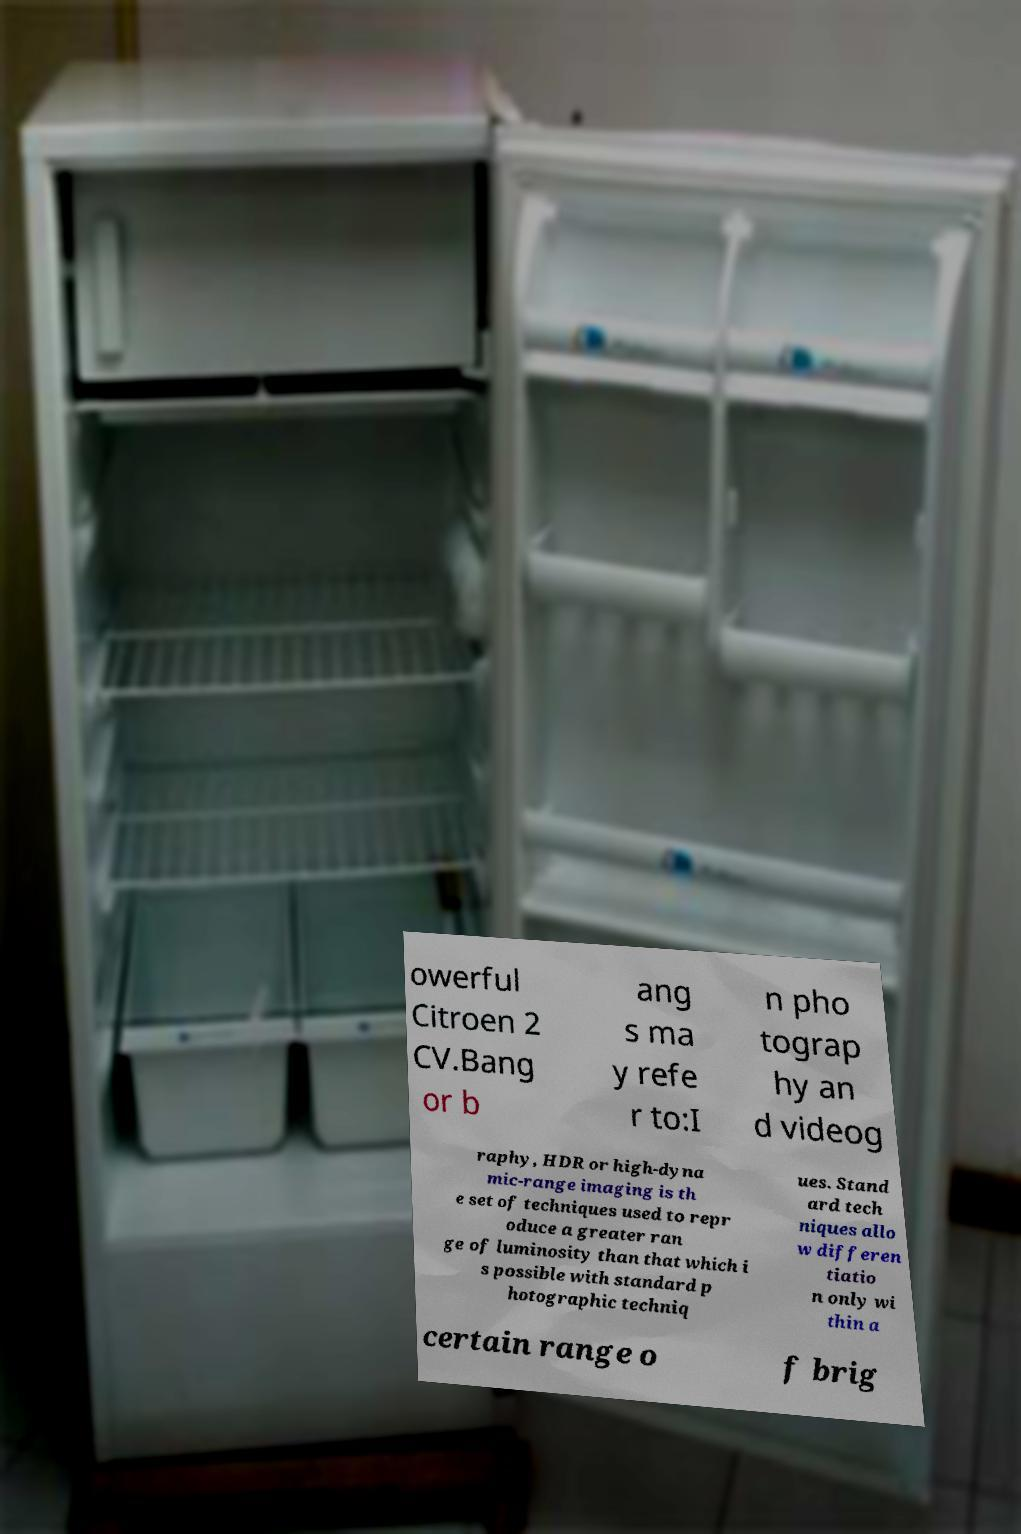For documentation purposes, I need the text within this image transcribed. Could you provide that? owerful Citroen 2 CV.Bang or b ang s ma y refe r to:I n pho tograp hy an d videog raphy, HDR or high-dyna mic-range imaging is th e set of techniques used to repr oduce a greater ran ge of luminosity than that which i s possible with standard p hotographic techniq ues. Stand ard tech niques allo w differen tiatio n only wi thin a certain range o f brig 